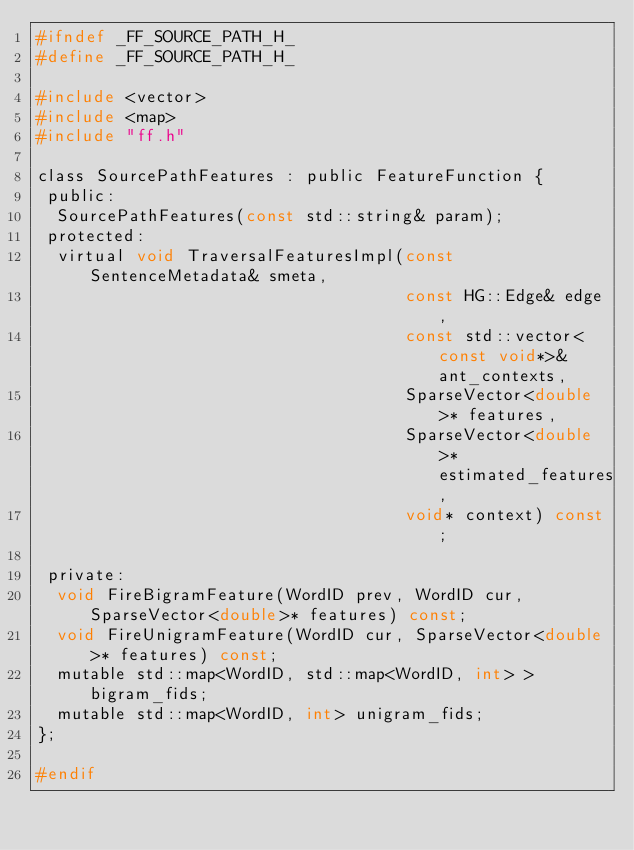<code> <loc_0><loc_0><loc_500><loc_500><_C_>#ifndef _FF_SOURCE_PATH_H_
#define _FF_SOURCE_PATH_H_

#include <vector>
#include <map>
#include "ff.h"

class SourcePathFeatures : public FeatureFunction {
 public:
  SourcePathFeatures(const std::string& param);
 protected:
  virtual void TraversalFeaturesImpl(const SentenceMetadata& smeta,
                                     const HG::Edge& edge,
                                     const std::vector<const void*>& ant_contexts,
                                     SparseVector<double>* features,
                                     SparseVector<double>* estimated_features,
                                     void* context) const;

 private:
  void FireBigramFeature(WordID prev, WordID cur, SparseVector<double>* features) const;
  void FireUnigramFeature(WordID cur, SparseVector<double>* features) const;
  mutable std::map<WordID, std::map<WordID, int> > bigram_fids;
  mutable std::map<WordID, int> unigram_fids;
};

#endif
</code> 